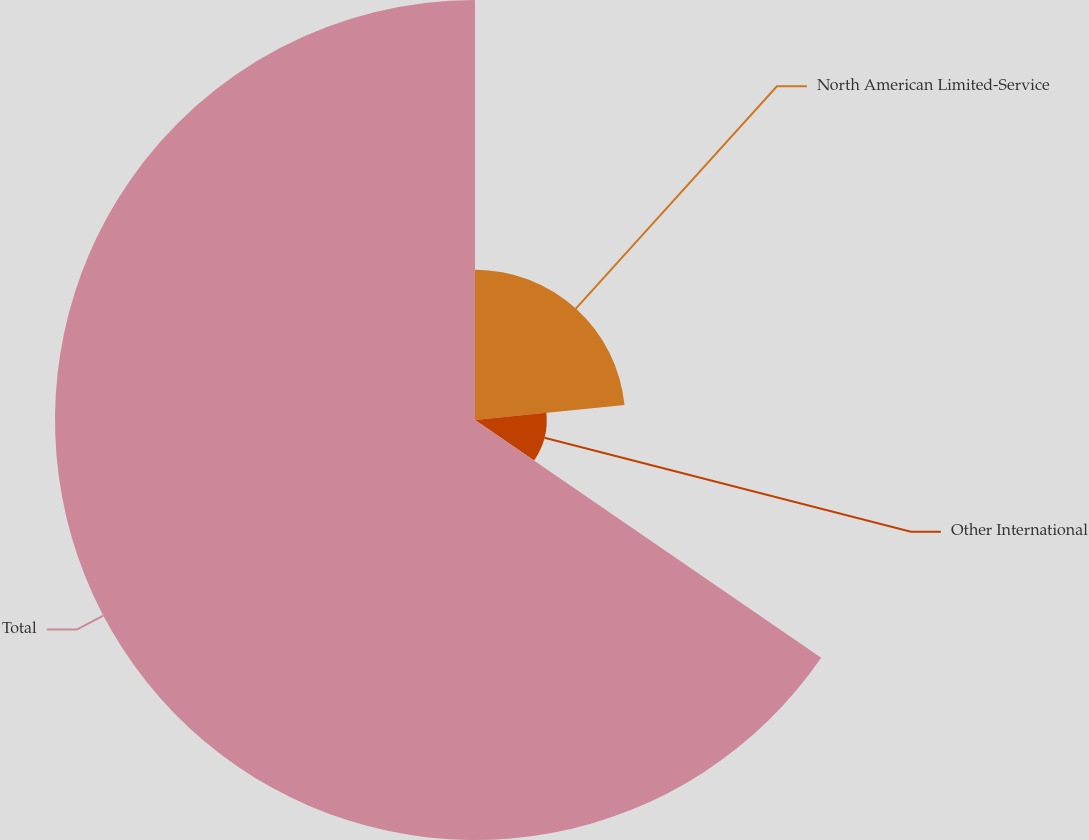<chart> <loc_0><loc_0><loc_500><loc_500><pie_chart><fcel>North American Limited-Service<fcel>Other International<fcel>Total<nl><fcel>23.41%<fcel>11.17%<fcel>65.42%<nl></chart> 